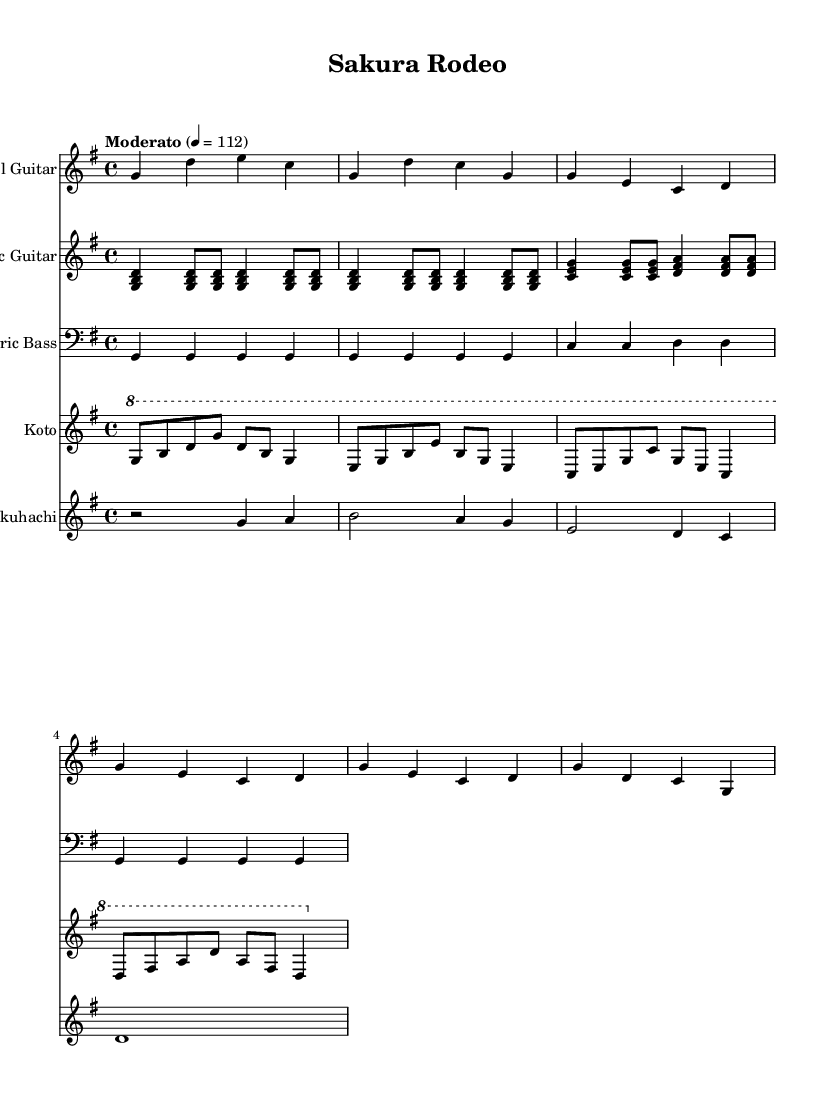What is the key signature of this music? The key signature is indicated in the global settings of the sheet music as G major, which has one sharp (F#).
Answer: G major What is the time signature of this music? The time signature appears in the global settings, and it shows that the music is in 4/4 time, meaning there are four beats in each measure.
Answer: 4/4 What is the tempo marking for the piece? The tempo marking is provided within the global settings indicating that the piece should be played at a moderato pace, which is typically around 112 beats per minute.
Answer: Moderato 4 = 112 How many measures are in the steel guitar part? To find the number of measures, count the individual segments represented by the vertical lines (bar lines) in the steel guitar part; there are a total of 6 measures.
Answer: 6 What instruments are featured in this piece? The instruments are listed at the beginning of each staff in the score; these include Steel Guitar, Acoustic Guitar, Electric Bass, Koto, and Shakuhachi.
Answer: Steel Guitar, Acoustic Guitar, Electric Bass, Koto, Shakuhachi What stylistic elements from country rock can be identified in the instrumentation? The instrumentation includes steel and acoustic guitars, commonly used in country rock, and the use of bass provides a solid rhythmic foundation.
Answer: Steel Guitar, Acoustic Guitar, Bass How does the use of shakuhachi affect the fusion genre? The shakuhachi adds a distinct Japanese timbre and cultural element, blending traditional sounds with the western country rock instrumentation, creating a unique fusion identity.
Answer: Adds Japanese timbre 